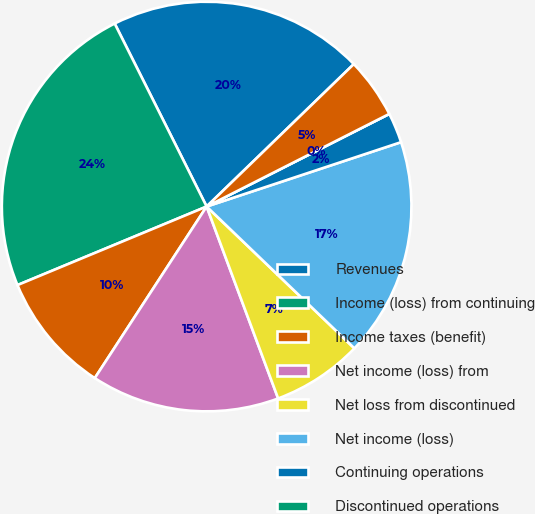Convert chart to OTSL. <chart><loc_0><loc_0><loc_500><loc_500><pie_chart><fcel>Revenues<fcel>Income (loss) from continuing<fcel>Income taxes (benefit)<fcel>Net income (loss) from<fcel>Net loss from discontinued<fcel>Net income (loss)<fcel>Continuing operations<fcel>Discontinued operations<fcel>Consolidated<nl><fcel>20.17%<fcel>23.85%<fcel>9.54%<fcel>14.87%<fcel>7.15%<fcel>17.26%<fcel>2.38%<fcel>0.0%<fcel>4.77%<nl></chart> 